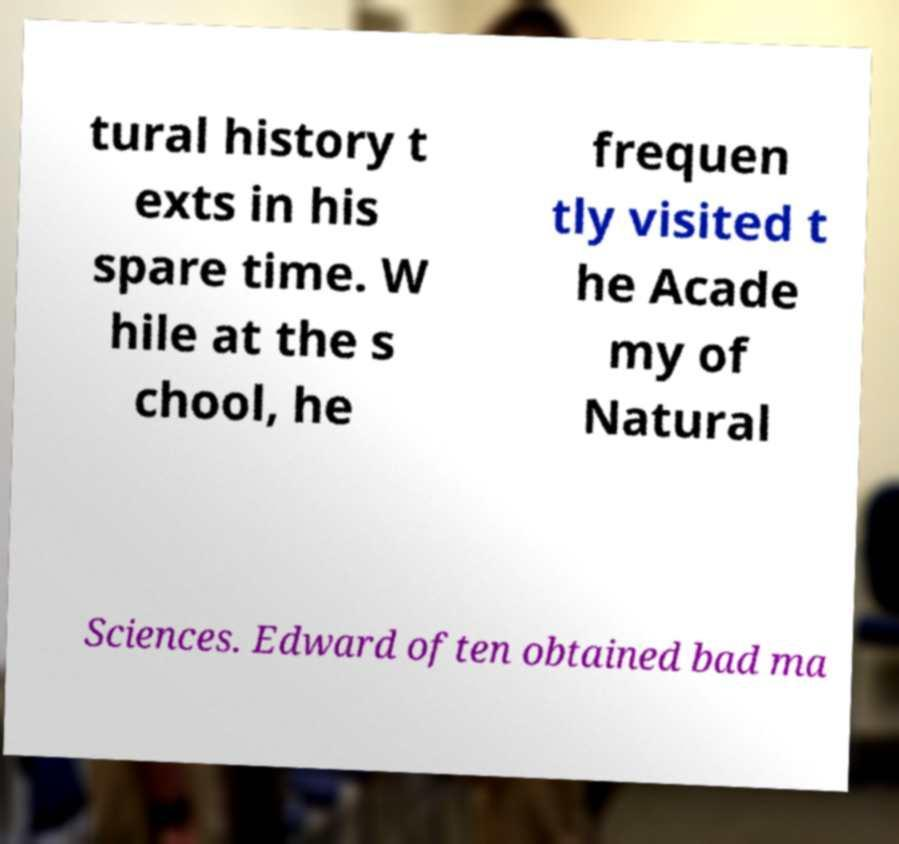For documentation purposes, I need the text within this image transcribed. Could you provide that? tural history t exts in his spare time. W hile at the s chool, he frequen tly visited t he Acade my of Natural Sciences. Edward often obtained bad ma 